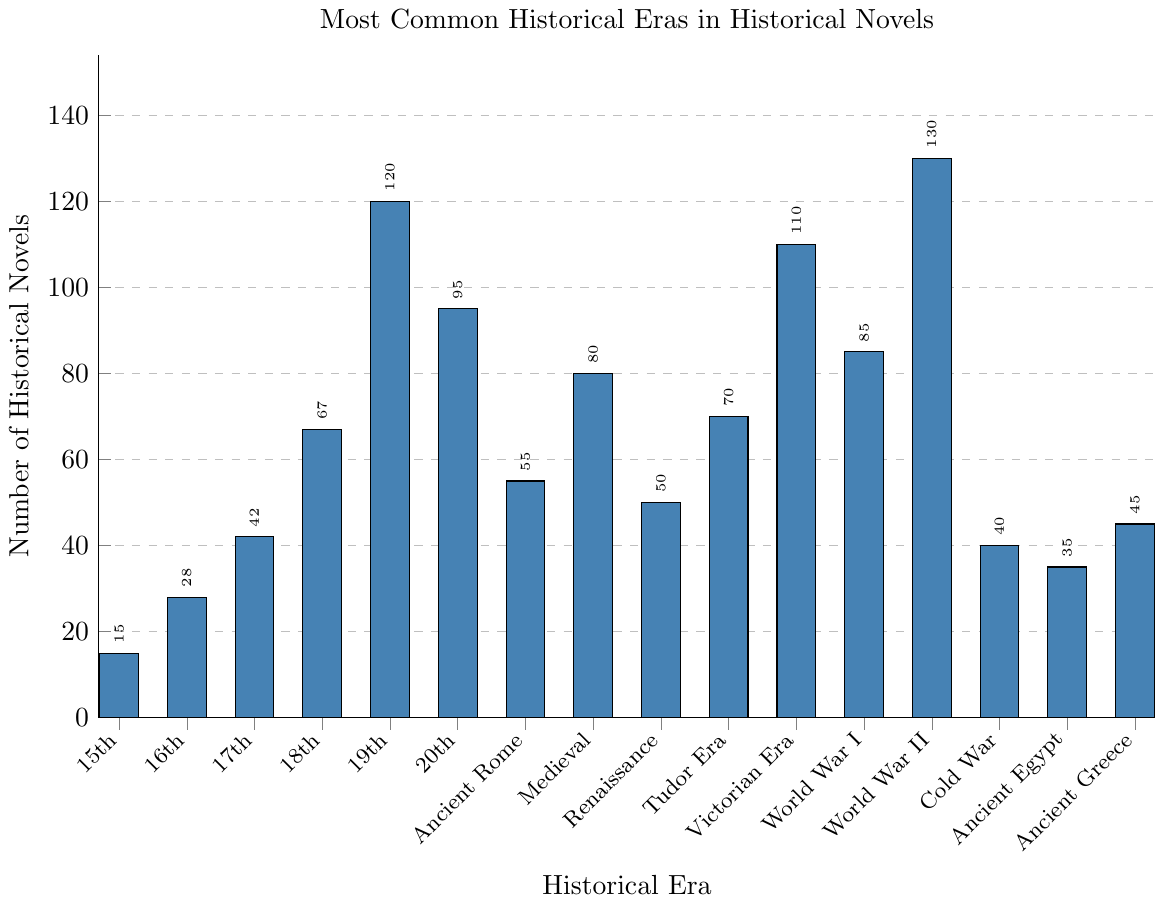Which historical era has the highest number of historical novels? Scan the heights of all the bars or refer to the labels displaying the number of historical novels for each era. The bar for World War II has the highest count at 130.
Answer: World War II Which century has fewer historical novels featured than the 18th century but more than the 15th century? Compare the data values for the 18th century (67) and the 15th century (15) with the other centuries. The 16th century (28) and the 17th century (42) both fall within this range, but the 17th century has fewer novels than the 18th century but more than the 15th century.
Answer: 17th century What is the combined number of historical novels for the Victorian Era and the Tudor Era? Find the numbers for the Victorian Era (110) and the Tudor Era (70). Compute their sum: 110 + 70 = 180.
Answer: 180 Is the number of historical novels set in Ancient Rome greater than those set in Ancient Egypt? Compare the heights or values of the bars for Ancient Rome (55) and Ancient Egypt (35). Ancient Rome has more novels.
Answer: Yes Which historical era has a similar number of novels as the Renaissance era? Find the number for the Renaissance era (50) and look for a bar with a height close to 50. The 20th century is the closest with 95, but exactly matching is Ancient Greece (45) and Tudor Era (70), which are close.
Answer: Ancient Greece What is the difference in the number of historical novels between the Medieval era and the 20th century? Find the numbers for the Medieval era (80) and the 20th century (95). Compute the difference: 95 - 80 = 15.
Answer: 15 Which has more novels: the 18th century or the 20th century? Compare the heights or values of the bars for the 18th century (67) and the 20th century (95). The 20th century has more novels.
Answer: 20th century Among the listed historical eras, which one has the second-highest number of historical novels? Identify the era with the highest count (World War II, 130), then find the next highest value, which is the 19th century (120).
Answer: 19th century What is the average number of historical novels for the 15th, 16th, and 17th centuries combined? Sum the values for the 15th (15), 16th (28), and 17th (42) centuries: 15 + 28 + 42 = 85. Then divide this by the number of centuries (3): 85/3 ≈ 28.3.
Answer: 28.3 How many more historical novels are there in the World War II era compared to the Cold War era? Find the values for World War II (130) and the Cold War (40). Compute the difference: 130 - 40 = 90.
Answer: 90 